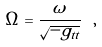Convert formula to latex. <formula><loc_0><loc_0><loc_500><loc_500>\Omega = \frac { \omega } { \sqrt { - g _ { t t } } } \ ,</formula> 